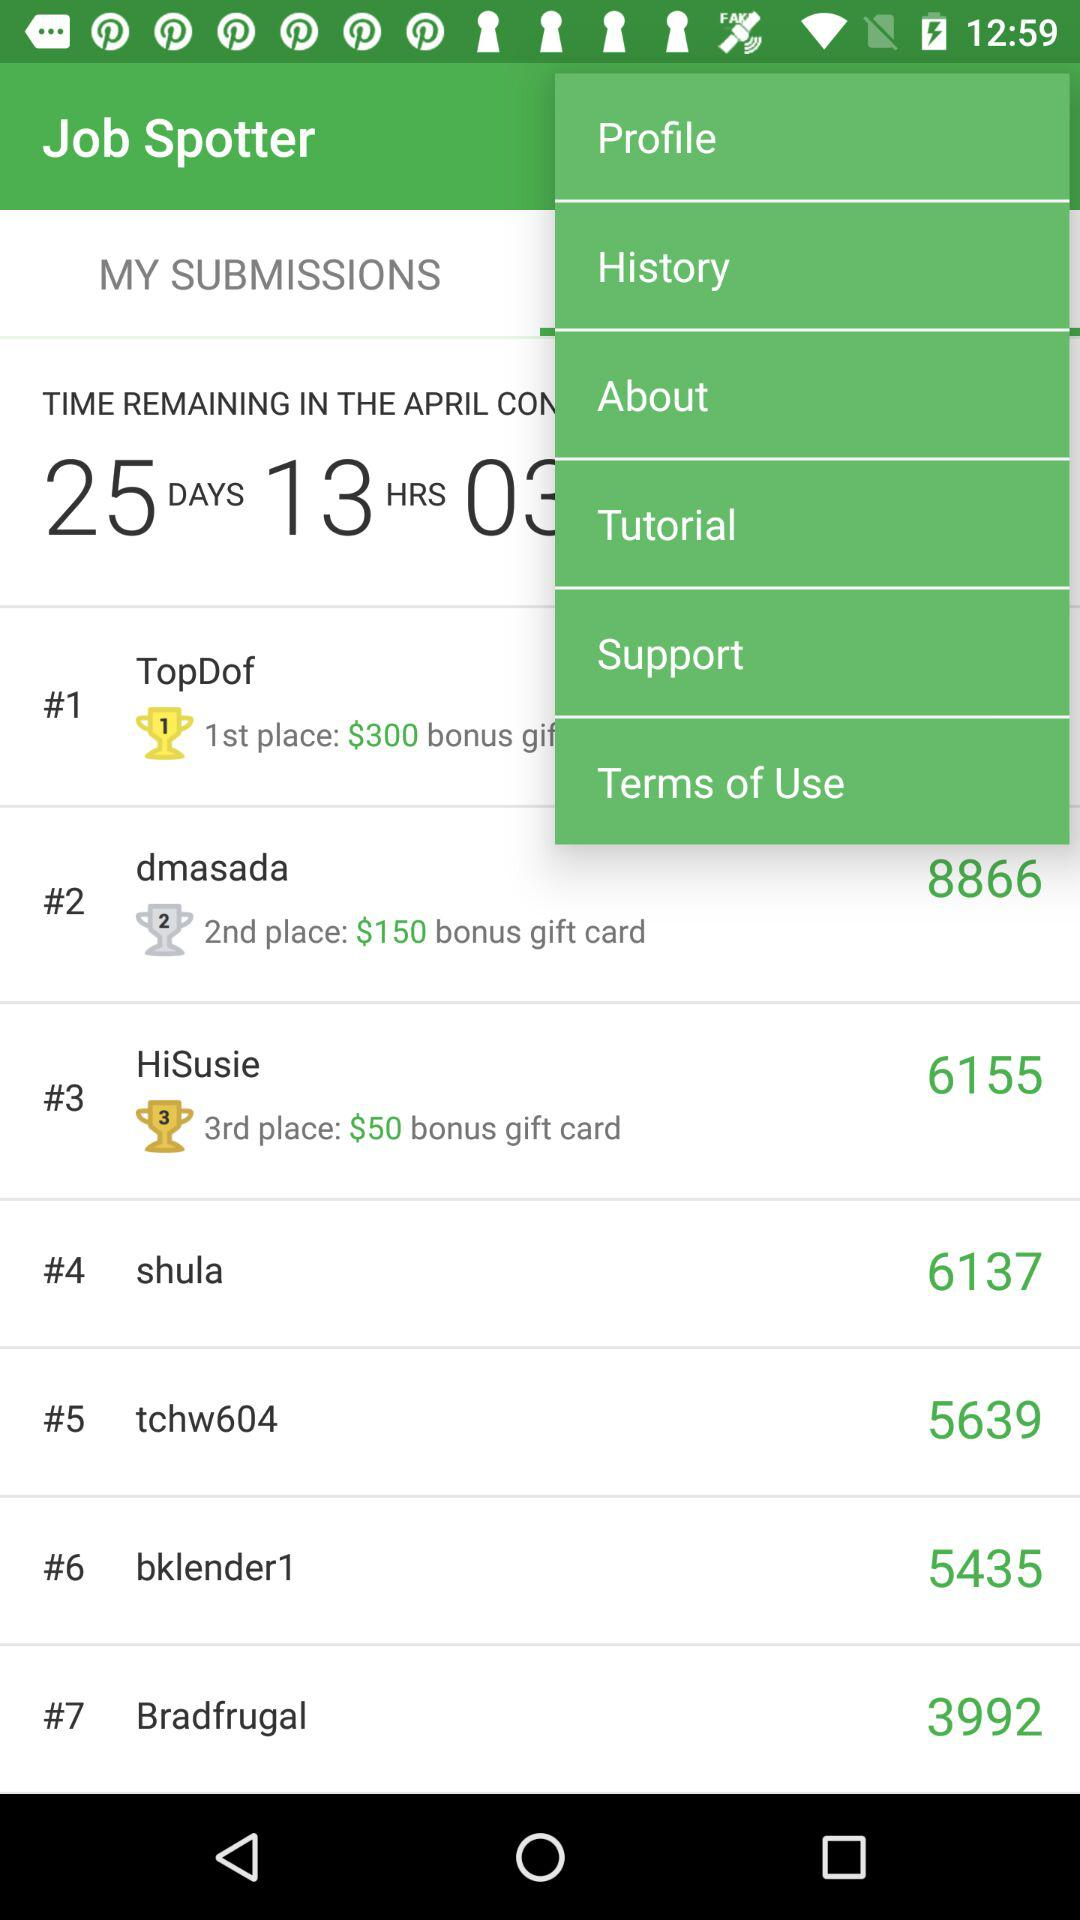How much is the bonus gift card amount for the 2nd place? The bonus gift card amount is $150 for the 2nd place. 